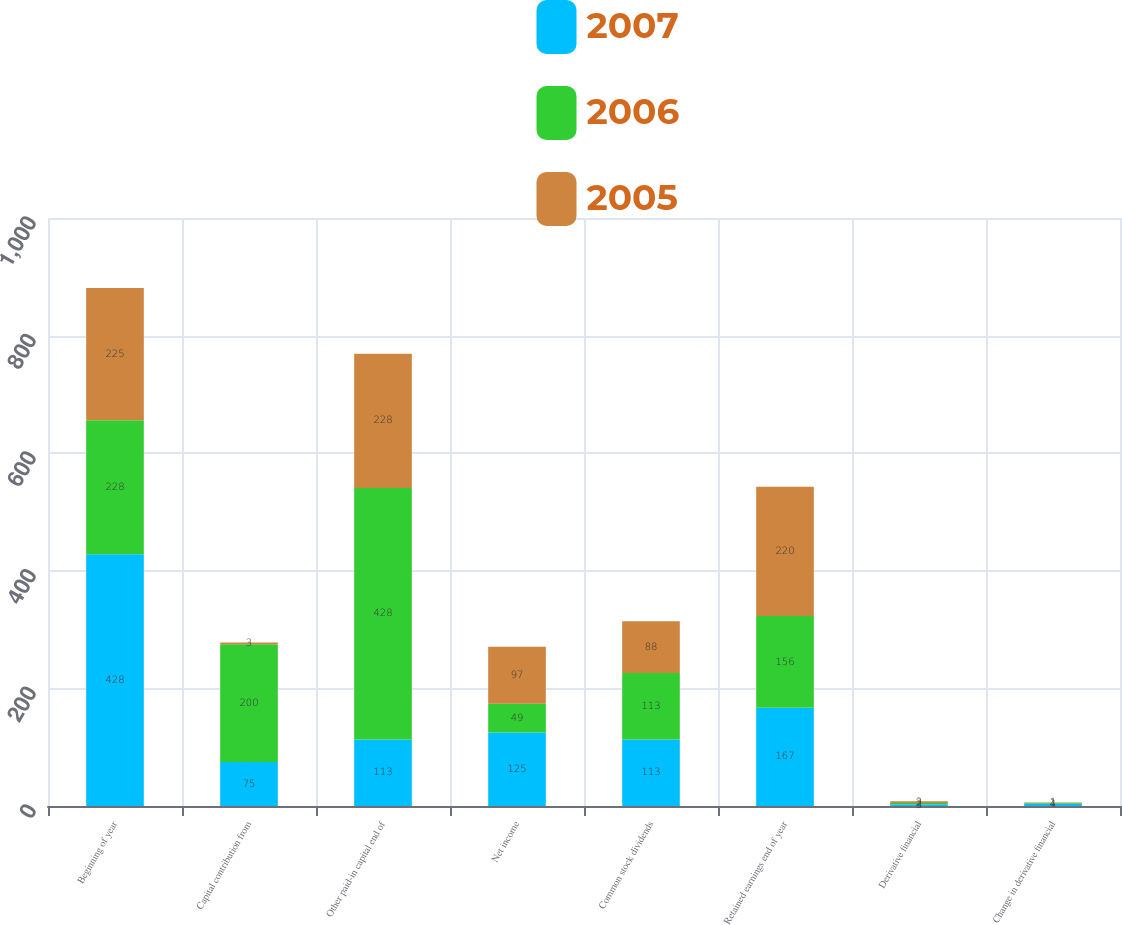Convert chart. <chart><loc_0><loc_0><loc_500><loc_500><stacked_bar_chart><ecel><fcel>Beginning of year<fcel>Capital contribution from<fcel>Other paid-in capital end of<fcel>Net income<fcel>Common stock dividends<fcel>Retained earnings end of year<fcel>Derivative financial<fcel>Change in derivative financial<nl><fcel>2007<fcel>428<fcel>75<fcel>113<fcel>125<fcel>113<fcel>167<fcel>3<fcel>4<nl><fcel>2006<fcel>228<fcel>200<fcel>428<fcel>49<fcel>113<fcel>156<fcel>2<fcel>1<nl><fcel>2005<fcel>225<fcel>3<fcel>228<fcel>97<fcel>88<fcel>220<fcel>3<fcel>1<nl></chart> 